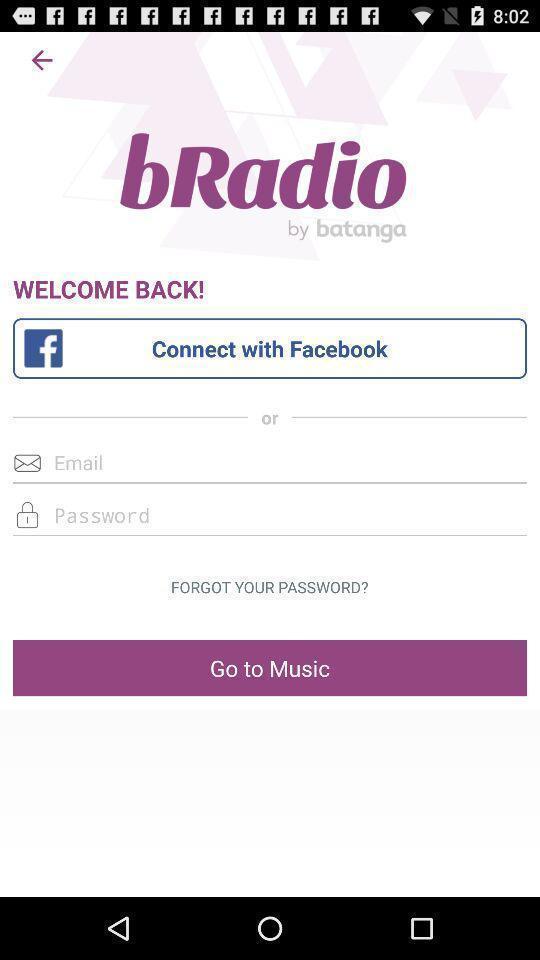Give me a narrative description of this picture. Welcome page with few options in music app. 